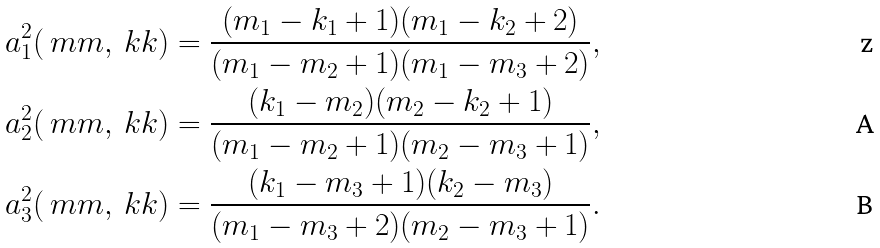Convert formula to latex. <formula><loc_0><loc_0><loc_500><loc_500>a _ { 1 } ^ { 2 } ( \ m m , \ k k ) & = \frac { ( m _ { 1 } - k _ { 1 } + 1 ) ( m _ { 1 } - k _ { 2 } + 2 ) } { ( m _ { 1 } - m _ { 2 } + 1 ) ( m _ { 1 } - m _ { 3 } + 2 ) } , \\ a _ { 2 } ^ { 2 } ( \ m m , \ k k ) & = \frac { ( k _ { 1 } - m _ { 2 } ) ( m _ { 2 } - k _ { 2 } + 1 ) } { ( m _ { 1 } - m _ { 2 } + 1 ) ( m _ { 2 } - m _ { 3 } + 1 ) } , \\ a _ { 3 } ^ { 2 } ( \ m m , \ k k ) & = \frac { ( k _ { 1 } - m _ { 3 } + 1 ) ( k _ { 2 } - m _ { 3 } ) } { ( m _ { 1 } - m _ { 3 } + 2 ) ( m _ { 2 } - m _ { 3 } + 1 ) } .</formula> 